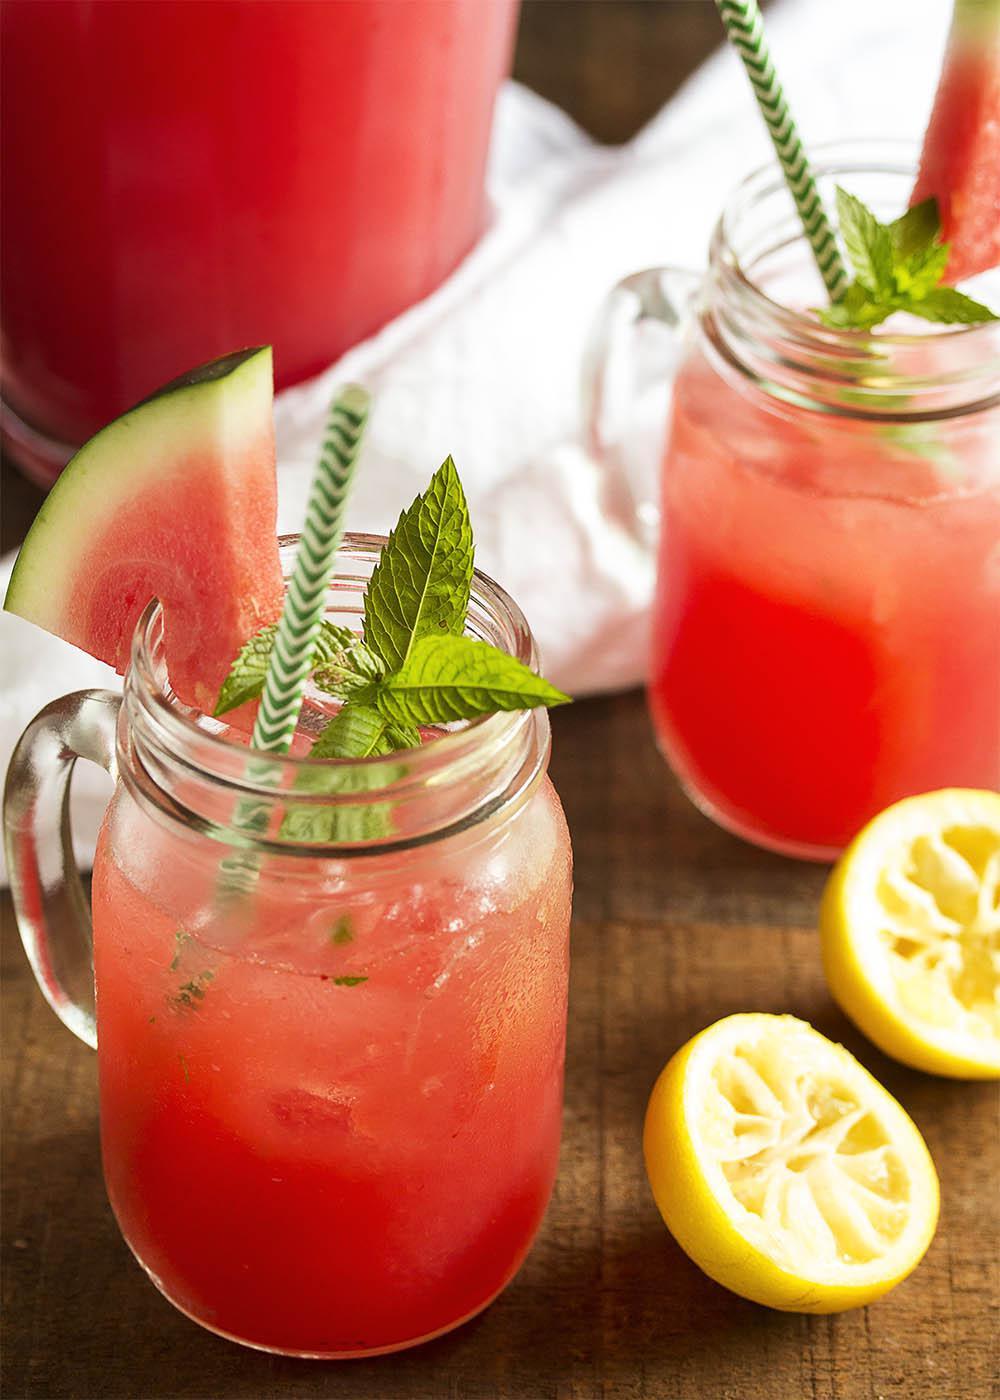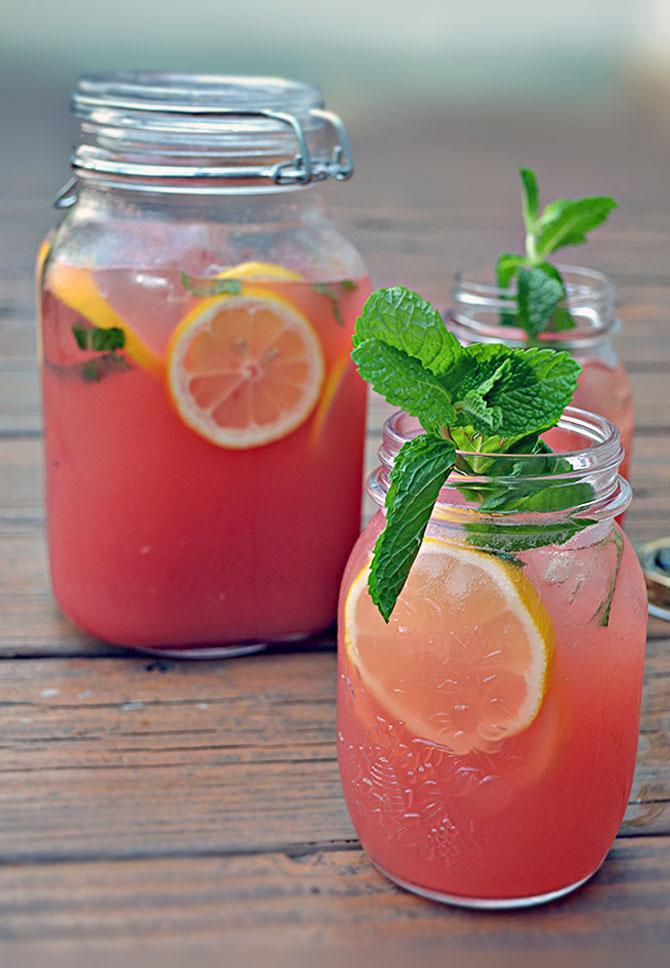The first image is the image on the left, the second image is the image on the right. Examine the images to the left and right. Is the description "An image shows exactly one drink garnished with a yellow citrus slice and green leaves." accurate? Answer yes or no. No. The first image is the image on the left, the second image is the image on the right. Examine the images to the left and right. Is the description "Exactly one prepared beverage glass is shown in each image." accurate? Answer yes or no. No. 